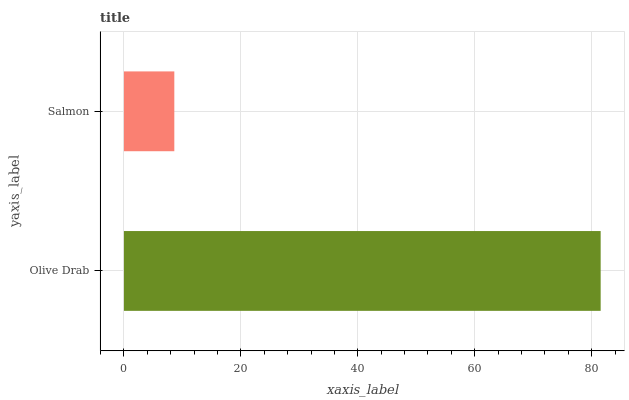Is Salmon the minimum?
Answer yes or no. Yes. Is Olive Drab the maximum?
Answer yes or no. Yes. Is Salmon the maximum?
Answer yes or no. No. Is Olive Drab greater than Salmon?
Answer yes or no. Yes. Is Salmon less than Olive Drab?
Answer yes or no. Yes. Is Salmon greater than Olive Drab?
Answer yes or no. No. Is Olive Drab less than Salmon?
Answer yes or no. No. Is Olive Drab the high median?
Answer yes or no. Yes. Is Salmon the low median?
Answer yes or no. Yes. Is Salmon the high median?
Answer yes or no. No. Is Olive Drab the low median?
Answer yes or no. No. 